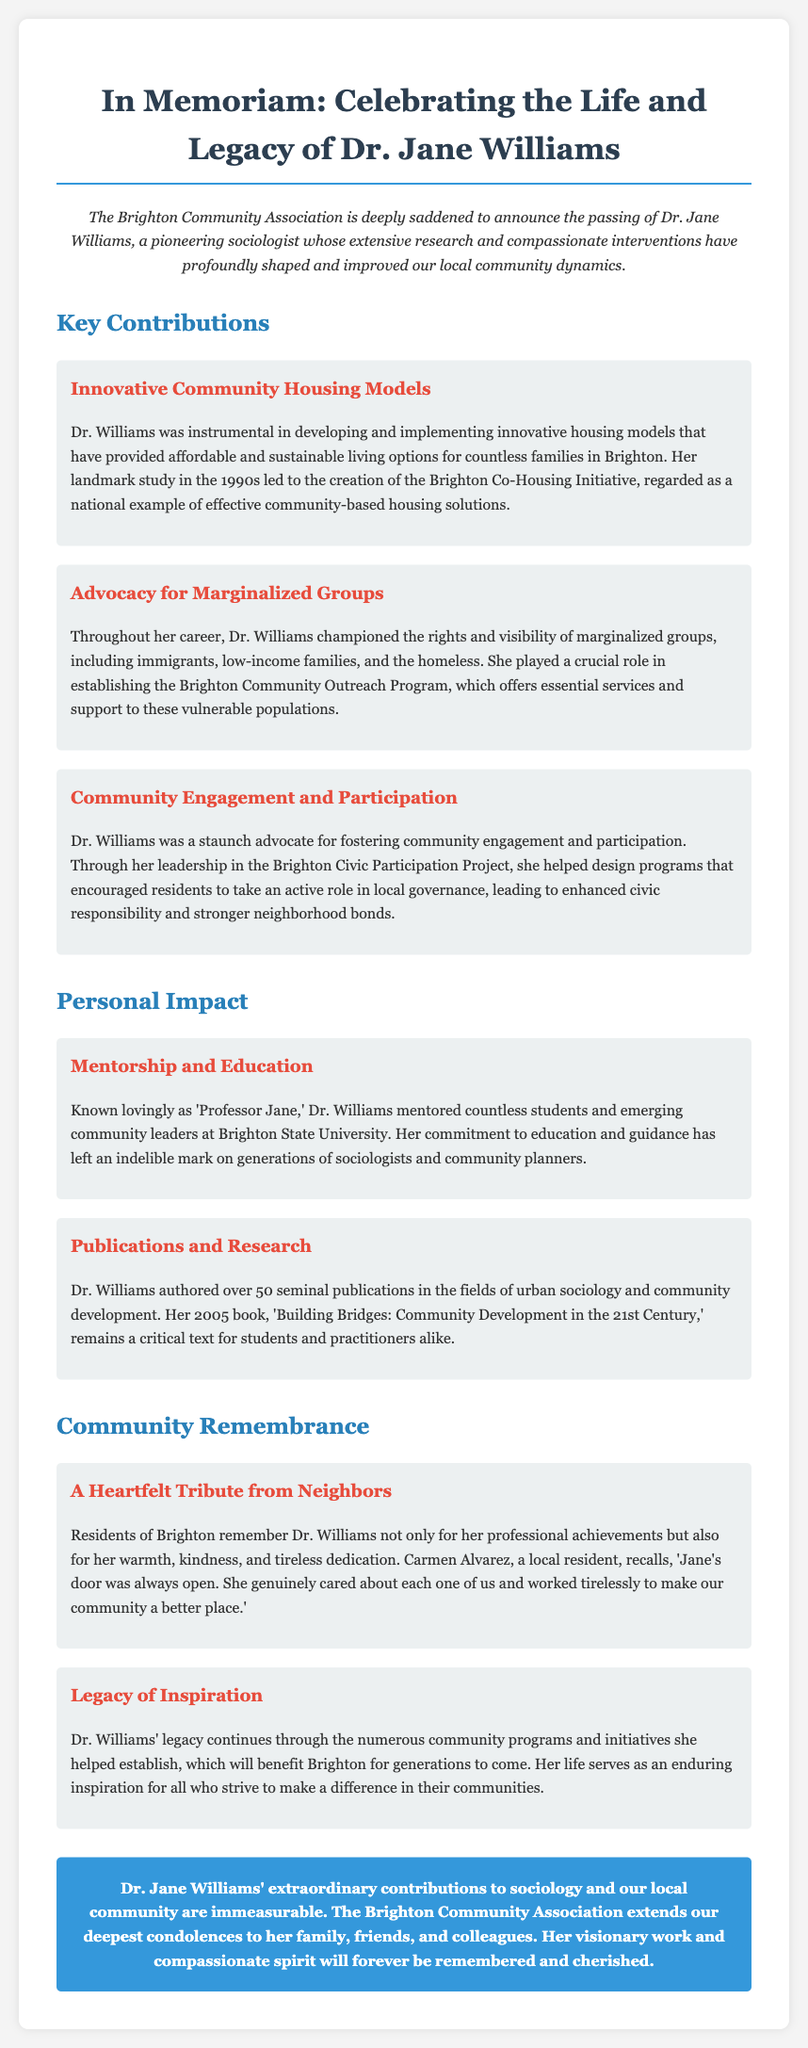What was Dr. Williams known as by her students? She was known lovingly as 'Professor Jane'.
Answer: Professor Jane What community initiative did Dr. Williams help create? The Brighton Co-Housing Initiative was a significant project she developed that focused on housing.
Answer: Brighton Co-Housing Initiative How many publications did Dr. Williams author? The document mentions over 50 seminal publications authored by Dr. Williams.
Answer: Over 50 What was one area Dr. Williams advocated for? She championed the rights and visibility of marginalized groups.
Answer: Marginalized groups What is the title of Dr. Williams' 2005 book? The book that remains a critical text is titled 'Building Bridges: Community Development in the 21st Century'.
Answer: Building Bridges: Community Development in the 21st Century How did local residents remember Dr. Williams? Residents recall her warmth, kindness, and tireless dedication to the community.
Answer: Warmth, kindness, and tireless dedication What program did Dr. Williams establish for vulnerable populations? She played a crucial role in establishing the Brighton Community Outreach Program.
Answer: Brighton Community Outreach Program What type of engagement did Dr. Williams advocate for? She promoted community engagement and active participation in local governance.
Answer: Community engagement How did Dr. Williams impact local governance? Her work led to enhanced civic responsibility and stronger neighborhood bonds.
Answer: Enhanced civic responsibility and stronger neighborhood bonds 